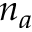Convert formula to latex. <formula><loc_0><loc_0><loc_500><loc_500>n _ { a }</formula> 